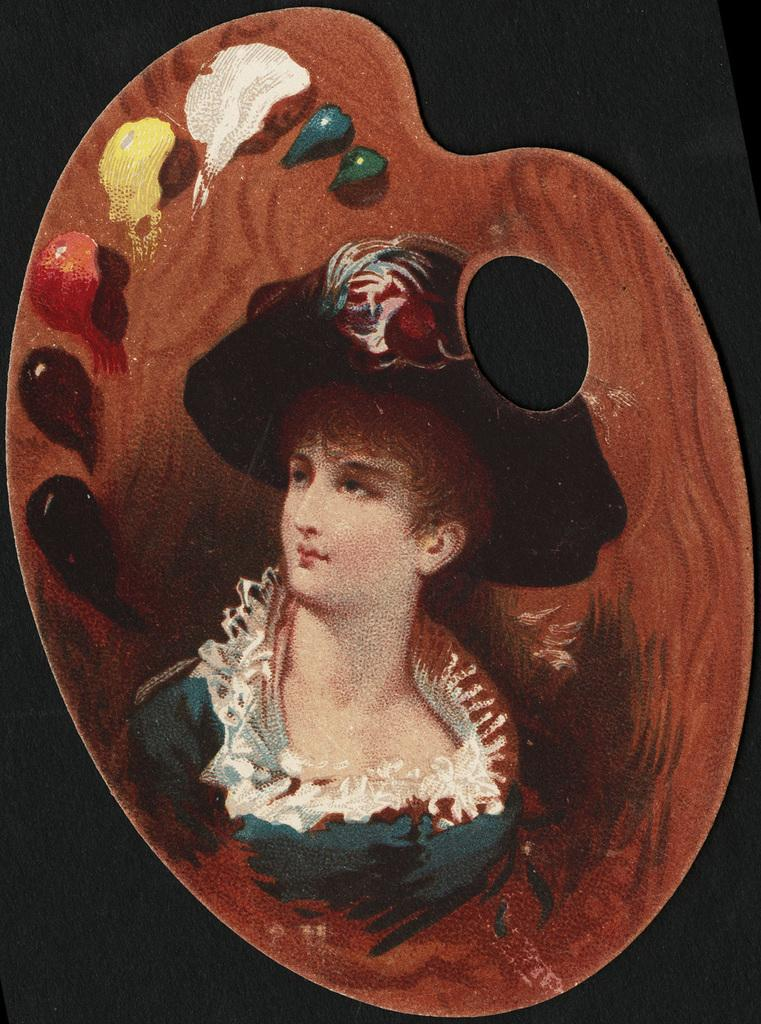What is the main subject of the painting in the image? The painting depicts a woman. What is the woman wearing on her head? The woman is wearing a hat. What color is the dress the woman is wearing? The woman is wearing a green dress. Where are the colors located in the image? The colors are on a plate on the left side of the image. What is the plot of the story being told by the woman in the painting? The painting does not depict a story or convey a plot; it is a static image of a woman wearing a hat and a green dress. 